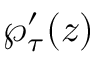<formula> <loc_0><loc_0><loc_500><loc_500>\wp _ { \tau } ^ { \prime } ( z )</formula> 